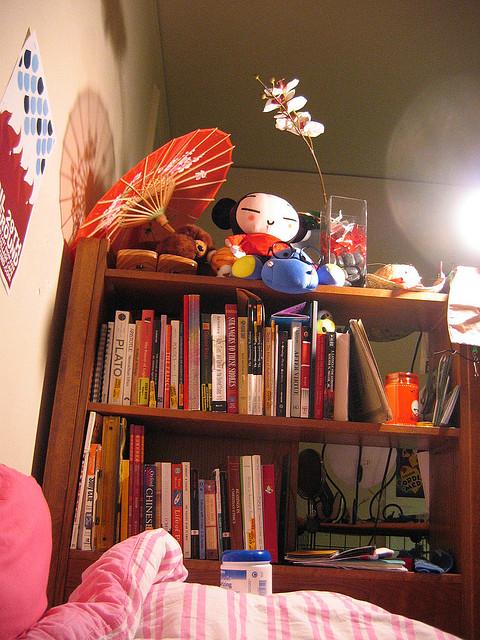What is the object on the left of the top shelf?
Be succinct. Umbrella. What are the bed sheets for?
Quick response, please. Sleeping. What color are the bed sheets?
Give a very brief answer. Pink. 